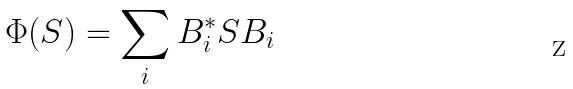Convert formula to latex. <formula><loc_0><loc_0><loc_500><loc_500>\Phi ( S ) = \sum _ { i } B _ { i } ^ { * } S B _ { i }</formula> 